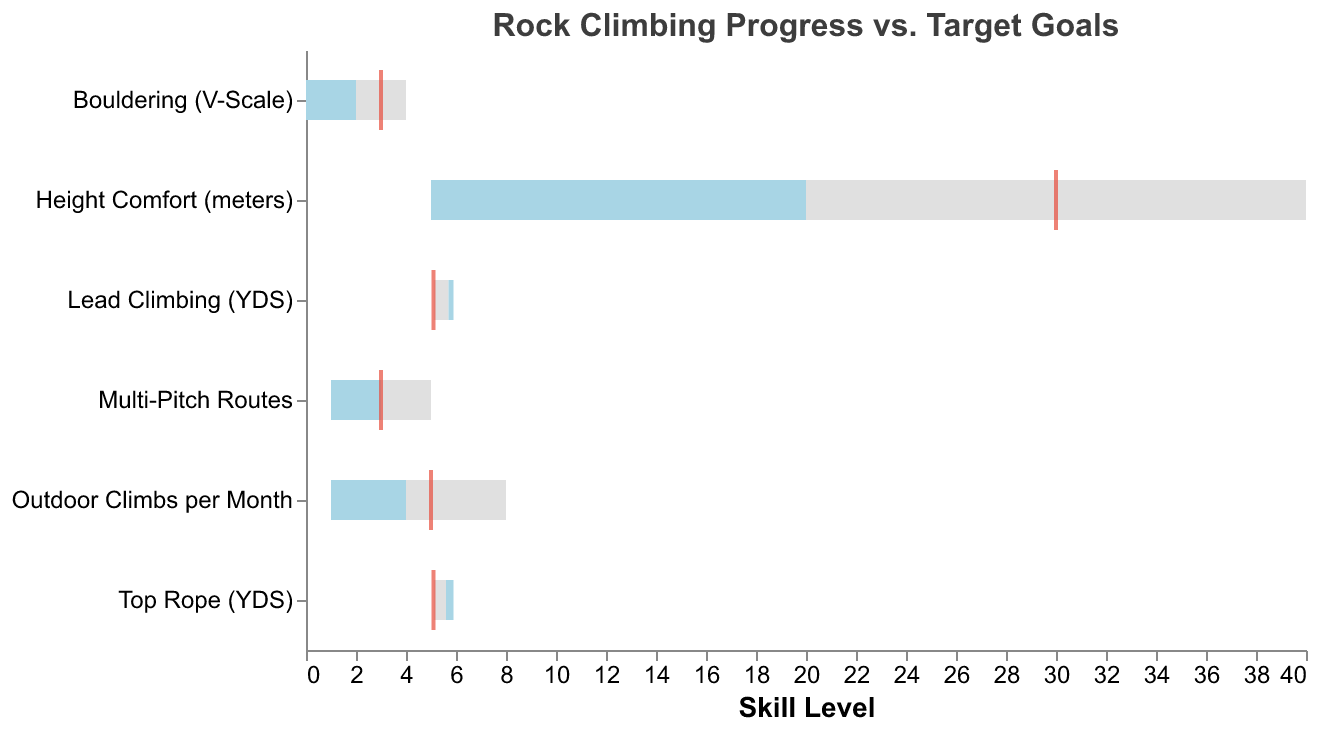What is the title of the chart? The title of the chart is at the top center and is usually the largest text on the chart.
Answer: Rock Climbing Progress vs. Target Goals What are the target goals for "Height Comfort (meters)"? The target goals in the chart are marked with red tick marks. Check where the red tick appears on the x-axis for the "Height Comfort (meters)" skill level.
Answer: 30 What is the actual skill level achieved for "Top Rope (YDS)"? The actual skill level is represented by blue bars. Look at the value of the blue bar for "Top Rope (YDS)".
Answer: 5.9 Which skill has the largest gap between the actual and the target? Calculate the difference between the actual (blue bar) and target (red tick) for each skill, then compare these differences to find the largest one.
Answer: Height Comfort (meters) How many skills have met or exceeded the intermediate level? Compare the actual level (blue bar) with the intermediate level (light blue bar). Count how many skills where the actual level falls within or beyond the light blue bar.
Answer: 3 Which skill has the smallest target goal? Check the red tick marks on the x-axis for all the skills and find the smallest value.
Answer: Multi-Pitch Routes Is there any skill where the actual level exceeds the intermediate level but does not reach the advanced level? Compare the actual level (blue bar) to both the intermediate (light blue bar) and advanced (gray bar) levels for each skill. Identify any skill where the actual level is between these two.
Answer: Bouldering (V-Scale) What is the intermediate level for "Outdoor Climbs per Month"? Intermediate levels are shown by the light blue bar. For "Outdoor Climbs per Month," find the value range covered by the light blue bar.
Answer: 4 Which skill has the actual level closest to the beginner level? Compare the actual level (blue bar) to the beginner level (start of gray bar) for each skill. Find the one with the smallest difference.
Answer: Lead Climbing (YDS) How does the height comfort actual level compare to its beginner and advanced levels? Check the blue bar for height comfort and see how it aligns with the start (beginner level) and end (advanced level) of the gray bar.
Answer: Actual level is above beginner (15 > 5) but below advanced (15 < 40) 